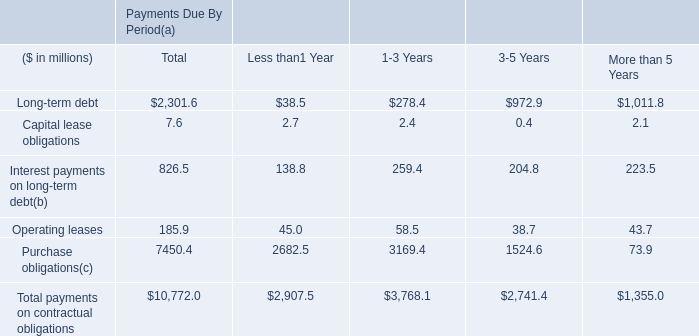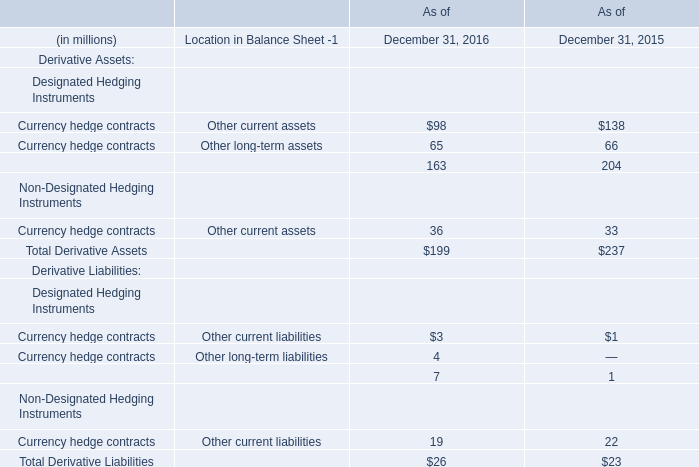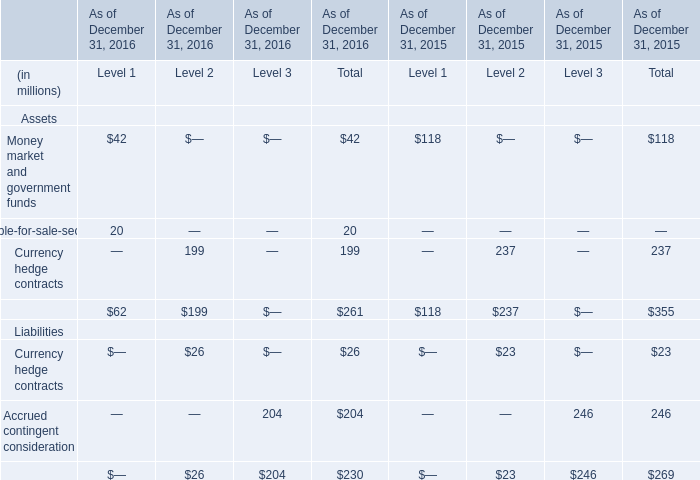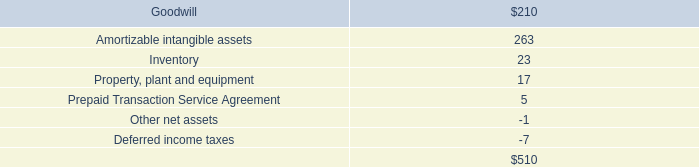What was the total amount of Total Derivative Assets in 2016 ? (in million) 
Answer: 199. 